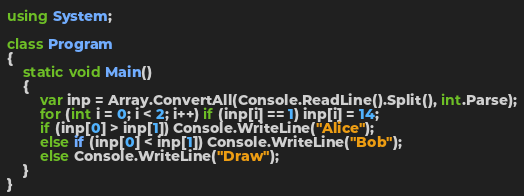Convert code to text. <code><loc_0><loc_0><loc_500><loc_500><_C#_>using System;

class Program
{
    static void Main()
    {
        var inp = Array.ConvertAll(Console.ReadLine().Split(), int.Parse);
        for (int i = 0; i < 2; i++) if (inp[i] == 1) inp[i] = 14;
        if (inp[0] > inp[1]) Console.WriteLine("Alice");
        else if (inp[0] < inp[1]) Console.WriteLine("Bob");
        else Console.WriteLine("Draw");
    }
}
</code> 